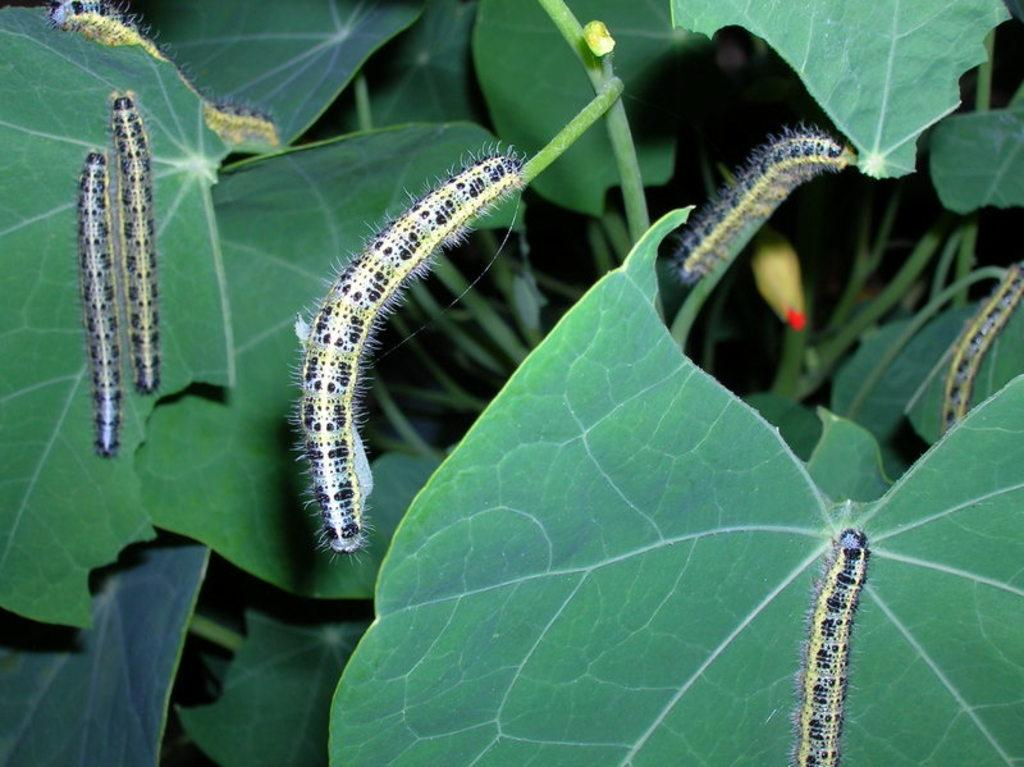What type of creatures are on the green leaves in the image? There are caterpillars on the green leaves in the image. What can be seen in the background of the image? In the background, there are leaves visible. Can you describe the color and appearance of the bud in the background? The bud in the background is in yellow and red color. Where is the giraffe in the image? There is no giraffe present in the image. What type of representative can be seen in the image? There is no representative present in the image; it features caterpillars, leaves, and a bud. 